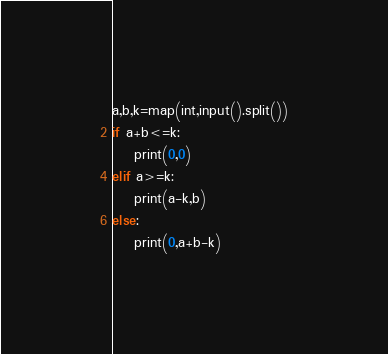<code> <loc_0><loc_0><loc_500><loc_500><_Python_>a,b,k=map(int,input().split())
if a+b<=k:
    print(0,0)
elif a>=k:
    print(a-k,b)
else:
    print(0,a+b-k)</code> 